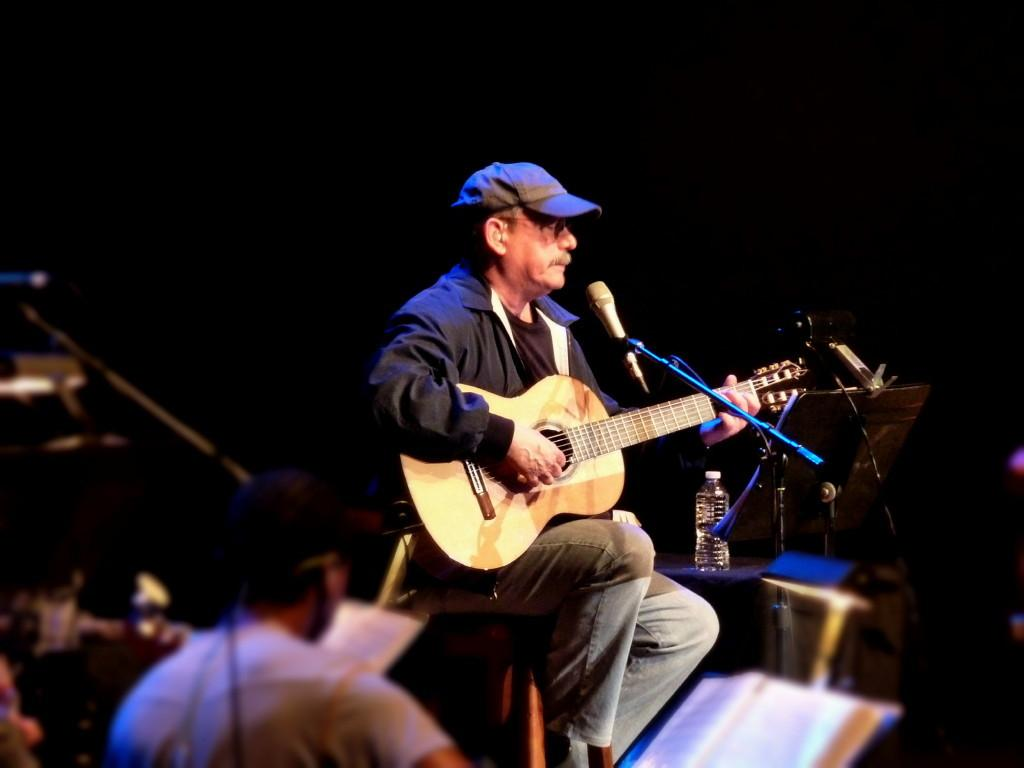What is the person on the chair doing in the image? The person is playing a guitar and singing on a microphone. Can you describe the position of the person on the chair? The person is sitting on a chair. What is the second person on the left side doing in the image? The second person is playing a musical instrument. What type of circle can be seen in the image? There is no circle present in the image. What is the shape of the person's mouth while singing on the microphone? The image does not provide enough detail to determine the shape of the person's mouth while singing. 